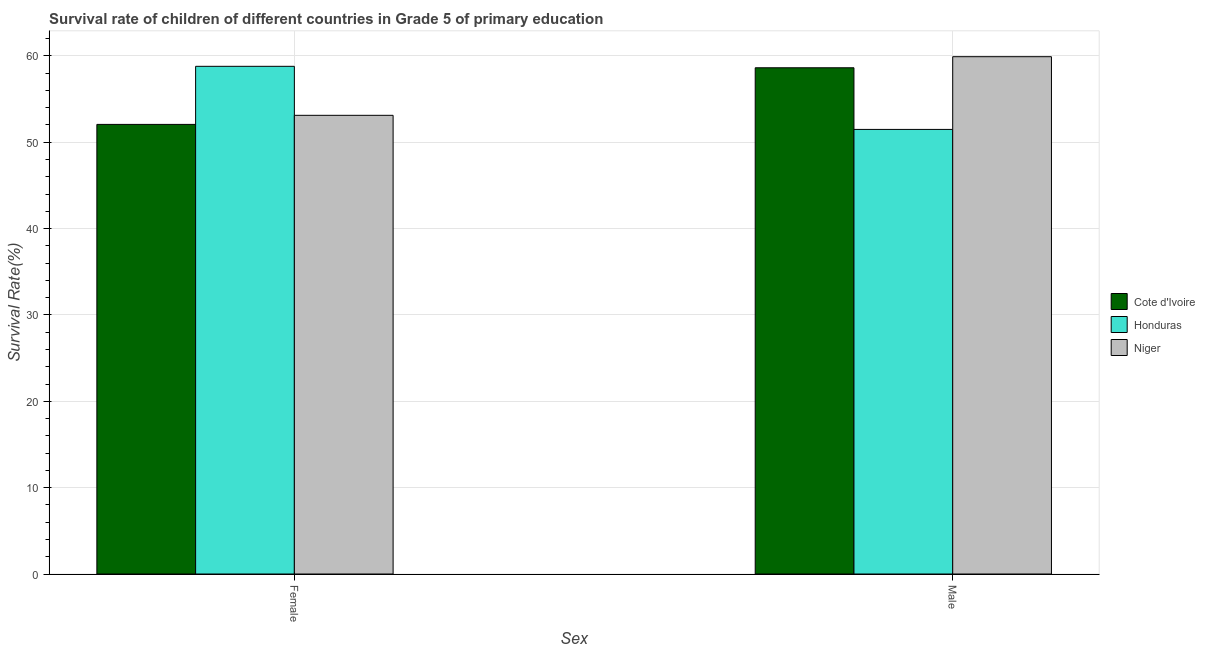How many different coloured bars are there?
Offer a terse response. 3. How many groups of bars are there?
Your response must be concise. 2. How many bars are there on the 2nd tick from the left?
Your answer should be compact. 3. What is the survival rate of male students in primary education in Niger?
Make the answer very short. 59.91. Across all countries, what is the maximum survival rate of female students in primary education?
Ensure brevity in your answer.  58.79. Across all countries, what is the minimum survival rate of male students in primary education?
Give a very brief answer. 51.49. In which country was the survival rate of male students in primary education maximum?
Your answer should be compact. Niger. In which country was the survival rate of female students in primary education minimum?
Offer a very short reply. Cote d'Ivoire. What is the total survival rate of male students in primary education in the graph?
Your answer should be very brief. 170.02. What is the difference between the survival rate of female students in primary education in Honduras and that in Cote d'Ivoire?
Ensure brevity in your answer.  6.72. What is the difference between the survival rate of male students in primary education in Honduras and the survival rate of female students in primary education in Niger?
Provide a succinct answer. -1.63. What is the average survival rate of male students in primary education per country?
Provide a succinct answer. 56.67. What is the difference between the survival rate of female students in primary education and survival rate of male students in primary education in Honduras?
Your response must be concise. 7.31. In how many countries, is the survival rate of male students in primary education greater than 28 %?
Your response must be concise. 3. What is the ratio of the survival rate of female students in primary education in Niger to that in Cote d'Ivoire?
Ensure brevity in your answer.  1.02. Is the survival rate of female students in primary education in Cote d'Ivoire less than that in Niger?
Give a very brief answer. Yes. In how many countries, is the survival rate of male students in primary education greater than the average survival rate of male students in primary education taken over all countries?
Provide a succinct answer. 2. What does the 2nd bar from the left in Female represents?
Offer a terse response. Honduras. What does the 3rd bar from the right in Female represents?
Give a very brief answer. Cote d'Ivoire. How many bars are there?
Provide a short and direct response. 6. What is the title of the graph?
Give a very brief answer. Survival rate of children of different countries in Grade 5 of primary education. Does "Sweden" appear as one of the legend labels in the graph?
Your answer should be very brief. No. What is the label or title of the X-axis?
Your answer should be very brief. Sex. What is the label or title of the Y-axis?
Your answer should be very brief. Survival Rate(%). What is the Survival Rate(%) in Cote d'Ivoire in Female?
Ensure brevity in your answer.  52.07. What is the Survival Rate(%) of Honduras in Female?
Offer a very short reply. 58.79. What is the Survival Rate(%) of Niger in Female?
Offer a terse response. 53.12. What is the Survival Rate(%) of Cote d'Ivoire in Male?
Make the answer very short. 58.63. What is the Survival Rate(%) in Honduras in Male?
Keep it short and to the point. 51.49. What is the Survival Rate(%) of Niger in Male?
Your answer should be very brief. 59.91. Across all Sex, what is the maximum Survival Rate(%) in Cote d'Ivoire?
Give a very brief answer. 58.63. Across all Sex, what is the maximum Survival Rate(%) of Honduras?
Offer a very short reply. 58.79. Across all Sex, what is the maximum Survival Rate(%) in Niger?
Provide a succinct answer. 59.91. Across all Sex, what is the minimum Survival Rate(%) of Cote d'Ivoire?
Your answer should be compact. 52.07. Across all Sex, what is the minimum Survival Rate(%) of Honduras?
Keep it short and to the point. 51.49. Across all Sex, what is the minimum Survival Rate(%) in Niger?
Ensure brevity in your answer.  53.12. What is the total Survival Rate(%) in Cote d'Ivoire in the graph?
Ensure brevity in your answer.  110.7. What is the total Survival Rate(%) of Honduras in the graph?
Provide a succinct answer. 110.28. What is the total Survival Rate(%) of Niger in the graph?
Provide a short and direct response. 113.03. What is the difference between the Survival Rate(%) of Cote d'Ivoire in Female and that in Male?
Provide a succinct answer. -6.56. What is the difference between the Survival Rate(%) of Honduras in Female and that in Male?
Offer a terse response. 7.31. What is the difference between the Survival Rate(%) in Niger in Female and that in Male?
Provide a short and direct response. -6.79. What is the difference between the Survival Rate(%) of Cote d'Ivoire in Female and the Survival Rate(%) of Honduras in Male?
Make the answer very short. 0.58. What is the difference between the Survival Rate(%) of Cote d'Ivoire in Female and the Survival Rate(%) of Niger in Male?
Offer a terse response. -7.84. What is the difference between the Survival Rate(%) of Honduras in Female and the Survival Rate(%) of Niger in Male?
Your answer should be very brief. -1.12. What is the average Survival Rate(%) of Cote d'Ivoire per Sex?
Offer a very short reply. 55.35. What is the average Survival Rate(%) of Honduras per Sex?
Offer a terse response. 55.14. What is the average Survival Rate(%) of Niger per Sex?
Make the answer very short. 56.52. What is the difference between the Survival Rate(%) of Cote d'Ivoire and Survival Rate(%) of Honduras in Female?
Give a very brief answer. -6.72. What is the difference between the Survival Rate(%) in Cote d'Ivoire and Survival Rate(%) in Niger in Female?
Ensure brevity in your answer.  -1.05. What is the difference between the Survival Rate(%) of Honduras and Survival Rate(%) of Niger in Female?
Keep it short and to the point. 5.67. What is the difference between the Survival Rate(%) of Cote d'Ivoire and Survival Rate(%) of Honduras in Male?
Give a very brief answer. 7.14. What is the difference between the Survival Rate(%) in Cote d'Ivoire and Survival Rate(%) in Niger in Male?
Give a very brief answer. -1.28. What is the difference between the Survival Rate(%) of Honduras and Survival Rate(%) of Niger in Male?
Give a very brief answer. -8.42. What is the ratio of the Survival Rate(%) of Cote d'Ivoire in Female to that in Male?
Ensure brevity in your answer.  0.89. What is the ratio of the Survival Rate(%) in Honduras in Female to that in Male?
Give a very brief answer. 1.14. What is the ratio of the Survival Rate(%) of Niger in Female to that in Male?
Make the answer very short. 0.89. What is the difference between the highest and the second highest Survival Rate(%) of Cote d'Ivoire?
Offer a terse response. 6.56. What is the difference between the highest and the second highest Survival Rate(%) of Honduras?
Your response must be concise. 7.31. What is the difference between the highest and the second highest Survival Rate(%) in Niger?
Make the answer very short. 6.79. What is the difference between the highest and the lowest Survival Rate(%) of Cote d'Ivoire?
Make the answer very short. 6.56. What is the difference between the highest and the lowest Survival Rate(%) of Honduras?
Your response must be concise. 7.31. What is the difference between the highest and the lowest Survival Rate(%) of Niger?
Give a very brief answer. 6.79. 